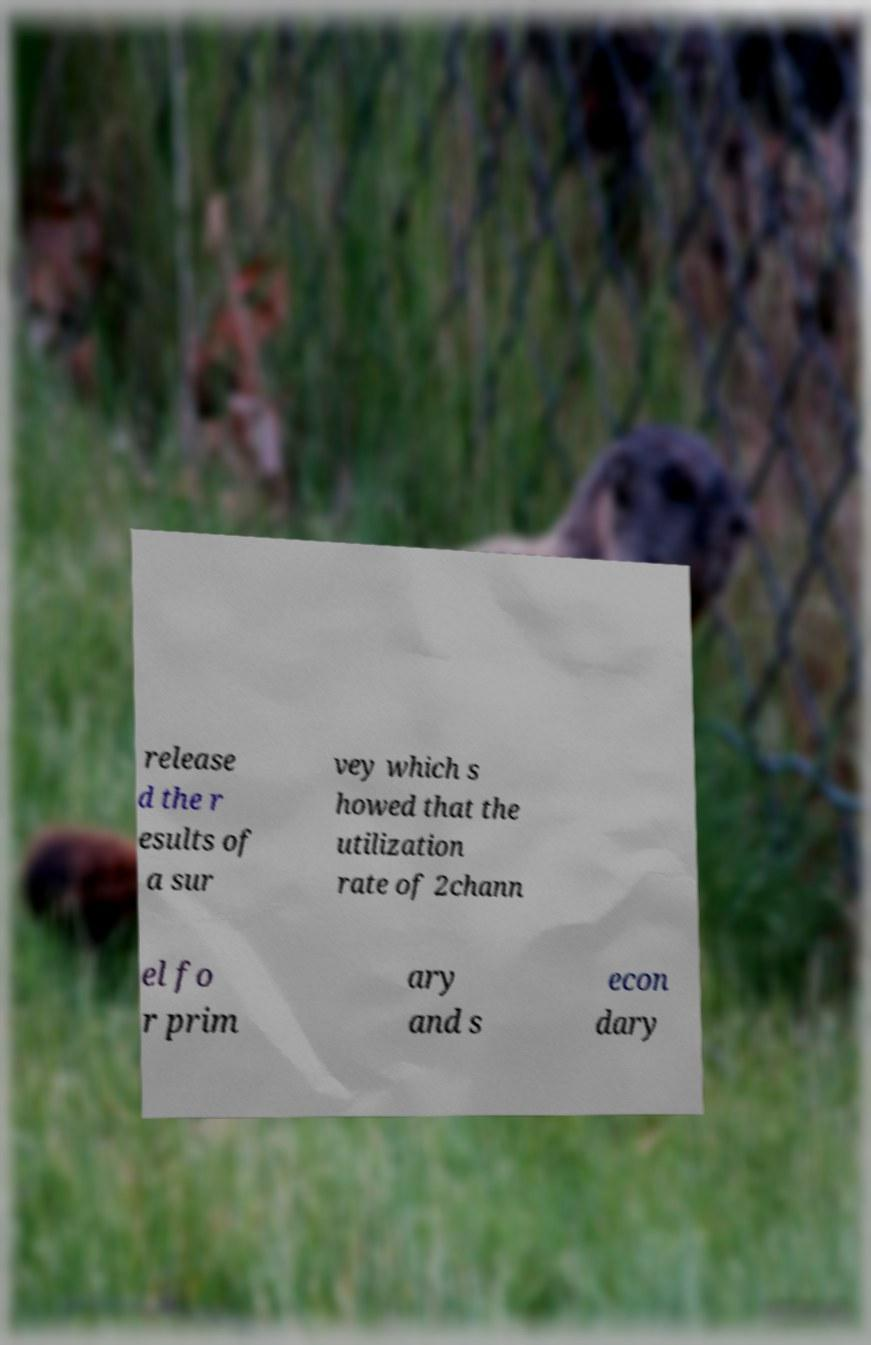For documentation purposes, I need the text within this image transcribed. Could you provide that? release d the r esults of a sur vey which s howed that the utilization rate of 2chann el fo r prim ary and s econ dary 